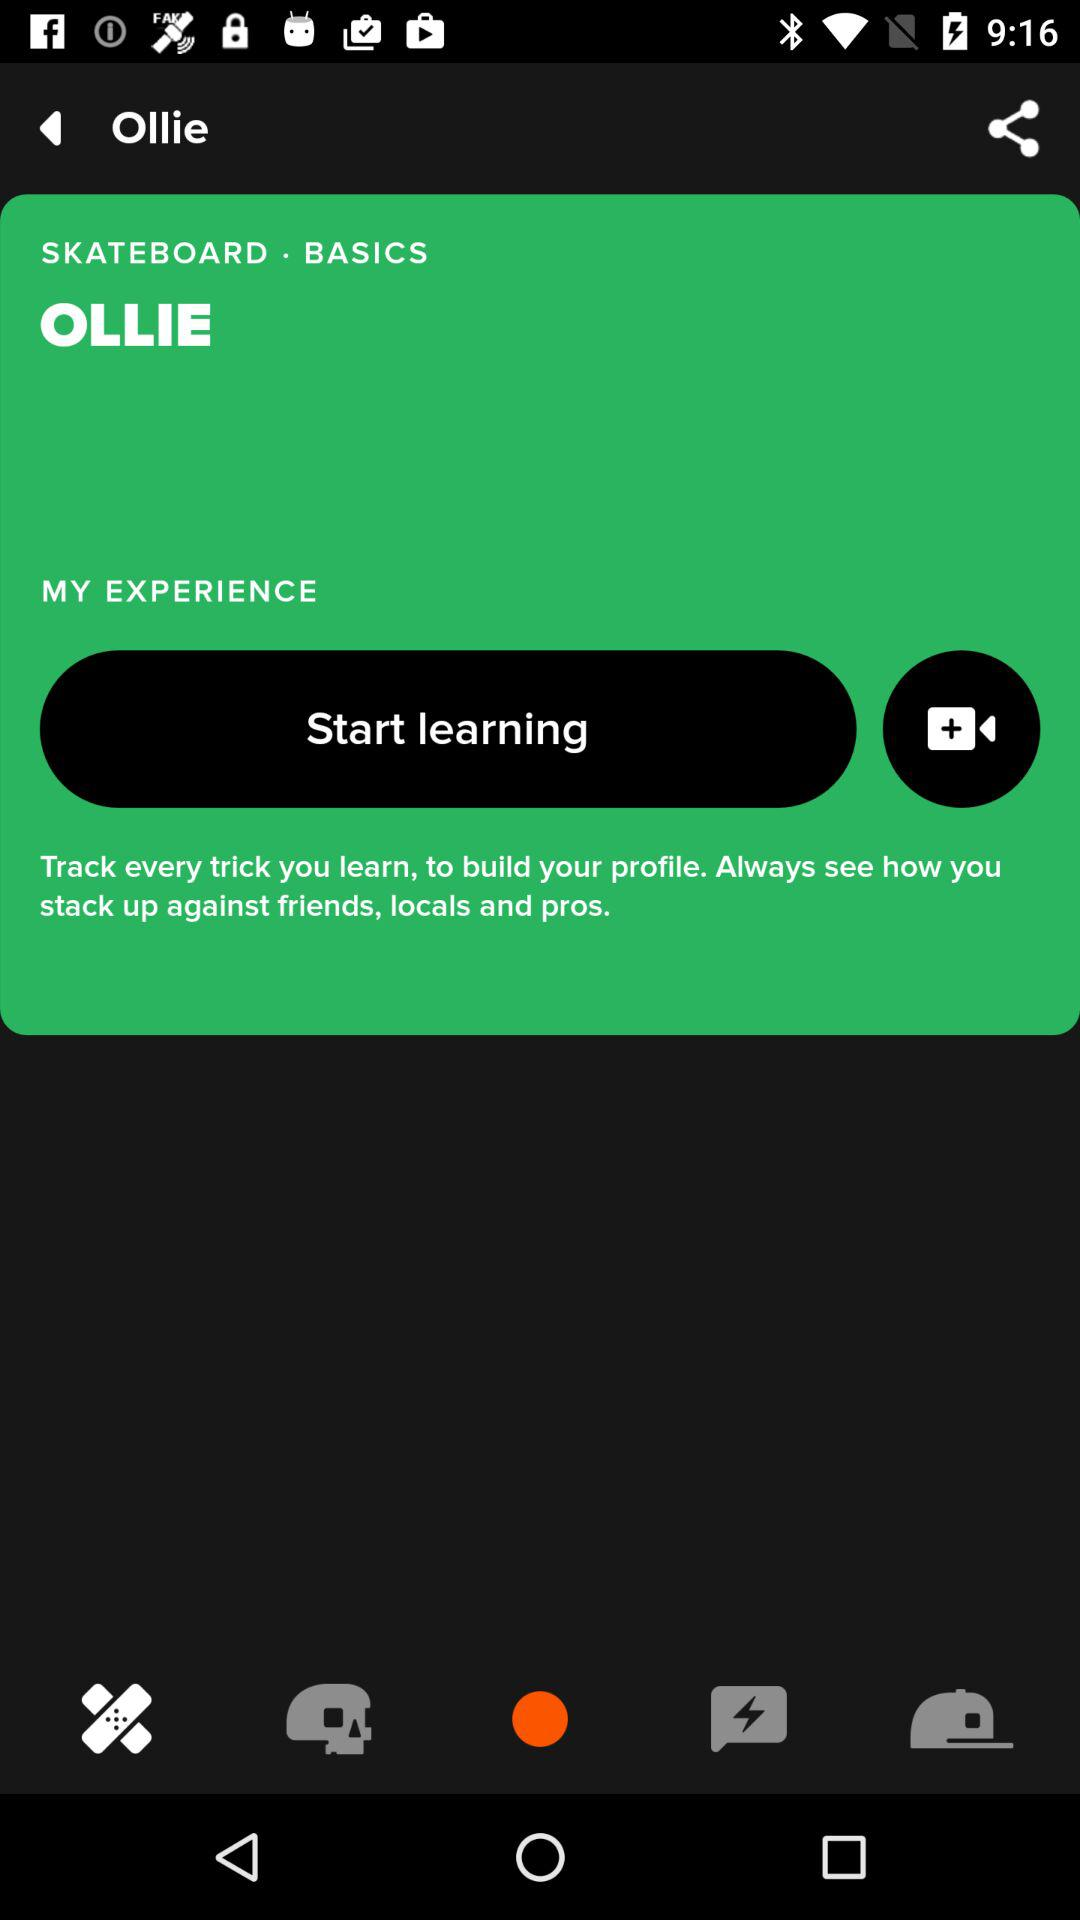What is the application name? The application name is "OLLIE". 